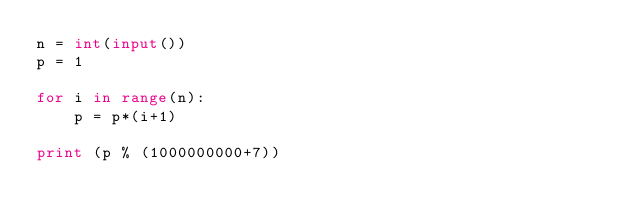Convert code to text. <code><loc_0><loc_0><loc_500><loc_500><_Python_>n = int(input())
p = 1

for i in range(n):
    p = p*(i+1)

print (p % (1000000000+7))
</code> 